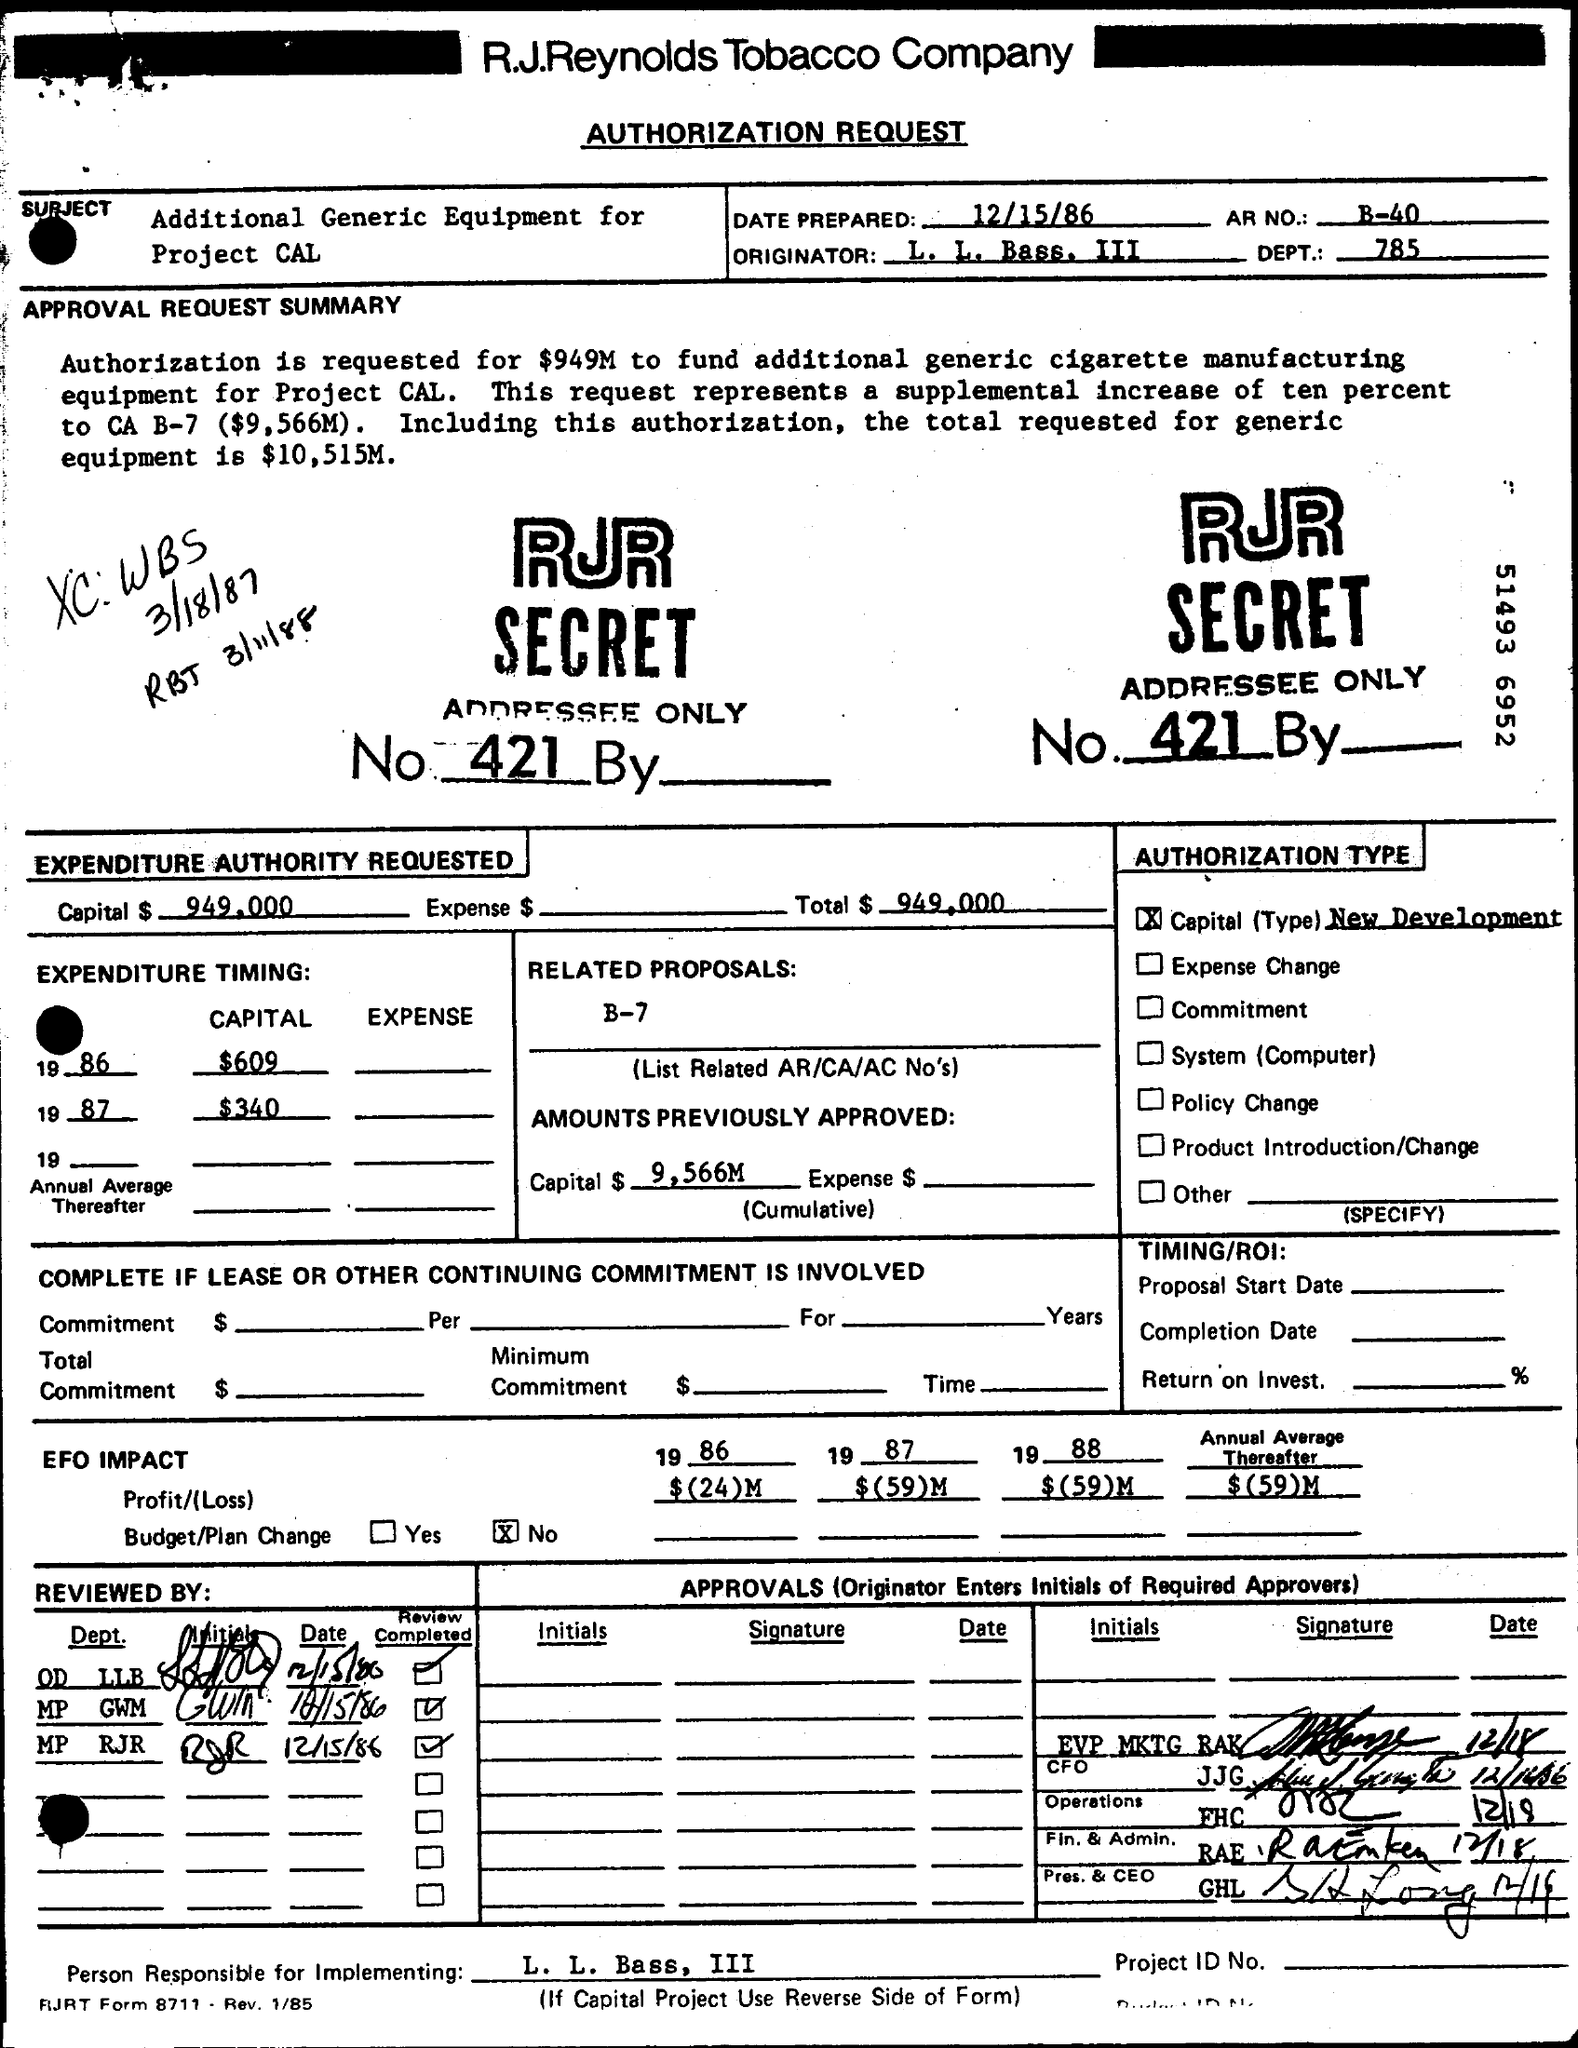What is the Title of the document?
Offer a terse response. Authorization Request. What is the Date Prepared?
Your response must be concise. 12/15/86. What is the AR NO.?
Your answer should be compact. B-40. What is the Dept?
Your answer should be compact. 785. What is the Capital?
Give a very brief answer. $949,000. What is the Total?
Your response must be concise. $ 949,000. Who is the Originator?
Offer a terse response. L. L. Bass. III. What is the Profit/(Loss) for 1986?
Keep it short and to the point. $(24)M. What is the Profit/(Loss) for 1987?
Offer a very short reply. $(59)M. What is the Profit/(Loss) for 1988?
Offer a terse response. $(59)M. 